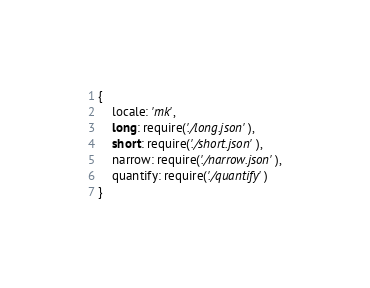Convert code to text. <code><loc_0><loc_0><loc_500><loc_500><_JavaScript_>{
	locale: 'mk',
	long: require('./long.json'),
	short: require('./short.json'),
	narrow: require('./narrow.json'),
	quantify: require('./quantify')
}</code> 